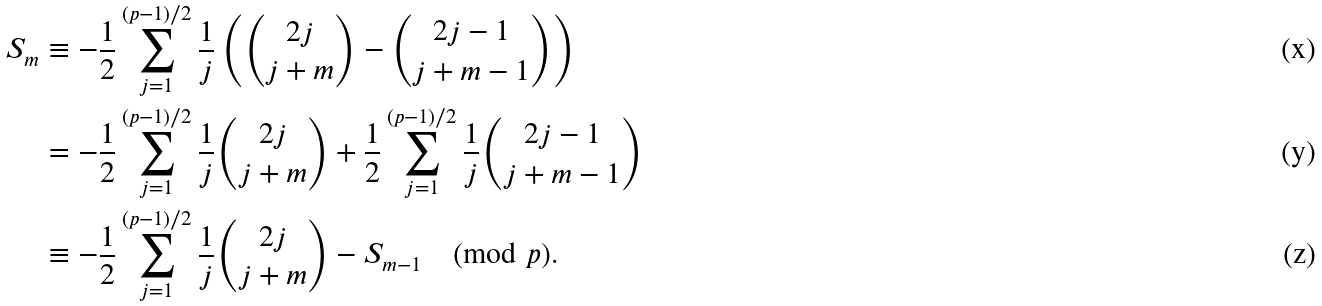<formula> <loc_0><loc_0><loc_500><loc_500>S _ { m } & \equiv - \frac { 1 } { 2 } \sum _ { j = 1 } ^ { ( p - 1 ) / 2 } \frac { 1 } { j } \left ( \binom { 2 j } { j + m } - \binom { 2 j - 1 } { j + m - 1 } \right ) \\ & = - \frac { 1 } { 2 } \sum _ { j = 1 } ^ { ( p - 1 ) / 2 } \frac { 1 } { j } \binom { 2 j } { j + m } + \frac { 1 } { 2 } \sum _ { j = 1 } ^ { ( p - 1 ) / 2 } \frac { 1 } { j } \binom { 2 j - 1 } { j + m - 1 } \\ & \equiv - \frac { 1 } { 2 } \sum _ { j = 1 } ^ { ( p - 1 ) / 2 } \frac { 1 } { j } \binom { 2 j } { j + m } - S _ { m - 1 } \pmod { p } .</formula> 